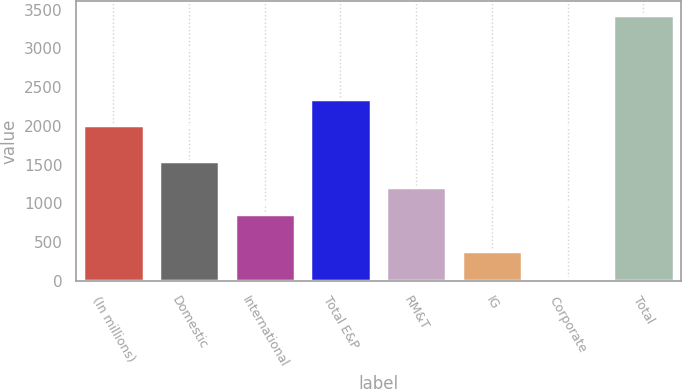Convert chart. <chart><loc_0><loc_0><loc_500><loc_500><bar_chart><fcel>(In millions)<fcel>Domestic<fcel>International<fcel>Total E&P<fcel>RM&T<fcel>IG<fcel>Corporate<fcel>Total<nl><fcel>2006<fcel>1545.4<fcel>867<fcel>2345.2<fcel>1206.2<fcel>380.2<fcel>41<fcel>3433<nl></chart> 